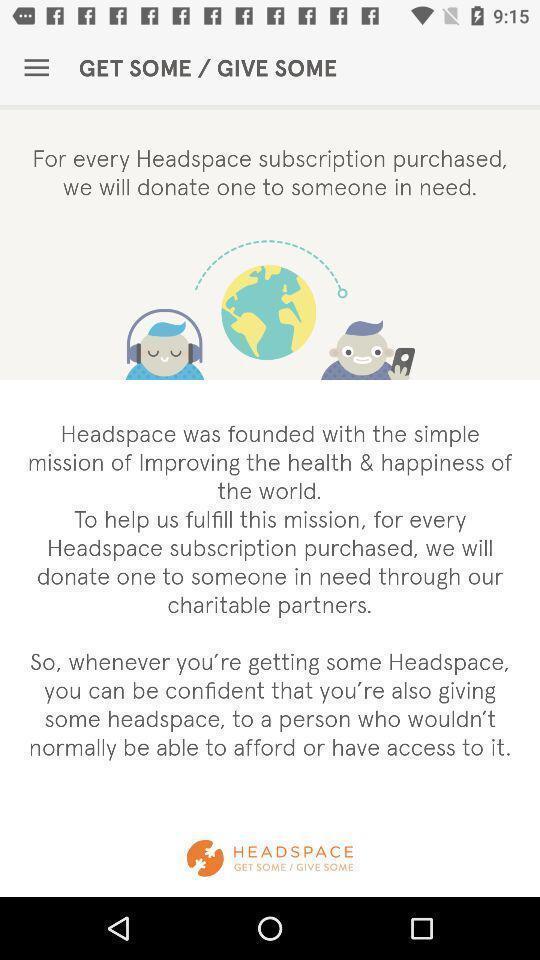Provide a detailed account of this screenshot. Window displaying an meditation app. 